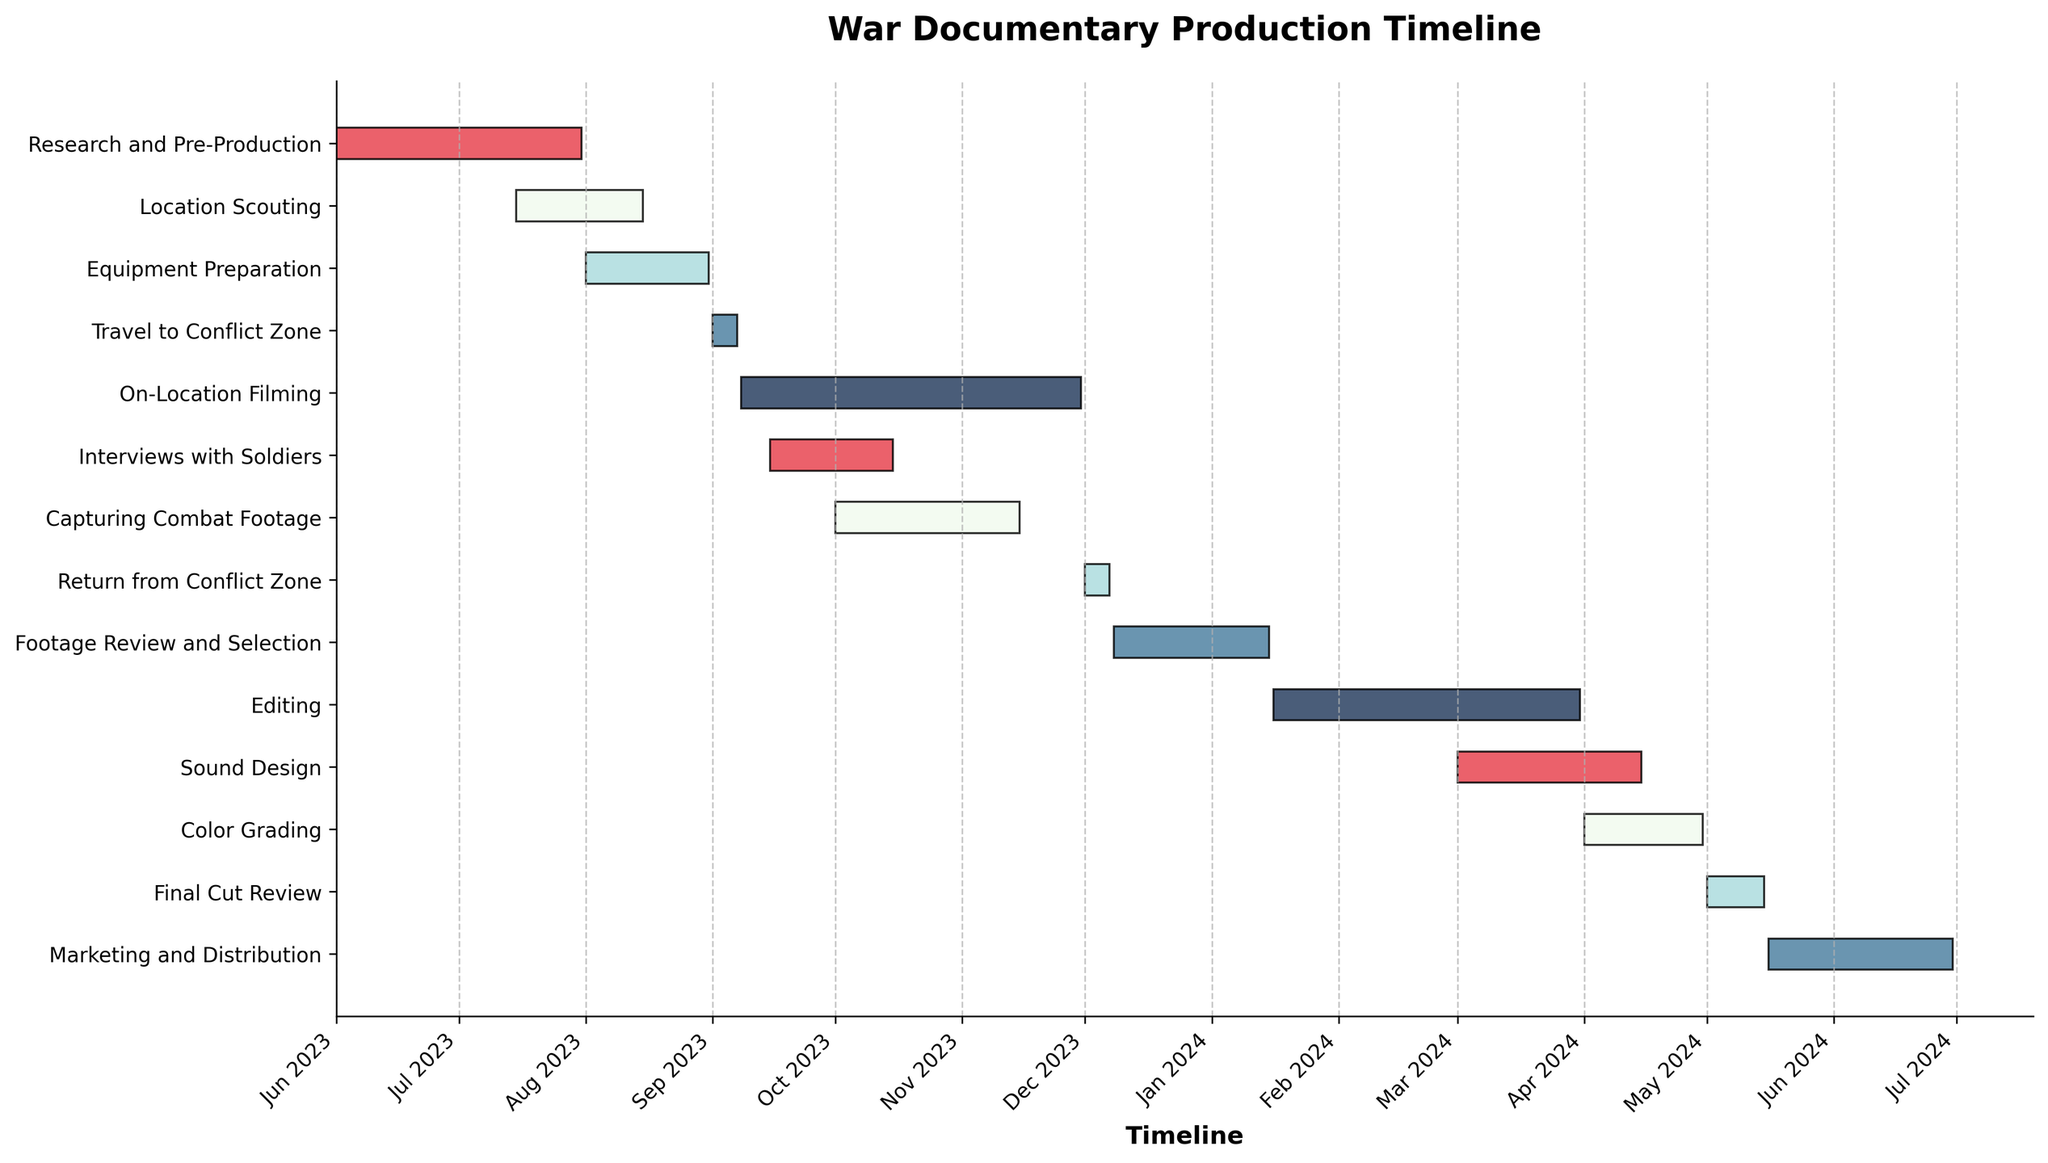What is the title of the Gantt Chart? The title of the Gantt Chart is displayed at the top center of the figure.
Answer: War Documentary Production Timeline What is the earliest task start date and which task does it belong to? By looking at the dates on the left side of each task bar, "Research and Pre-Production" starts on June 1, 2023, which is the earliest date.
Answer: June 1, 2023; Research and Pre-Production How many tasks are in the Filming phase? By examining the task list, the Filming phase includes "Travel to Conflict Zone", "On-Location Filming", "Interviews with Soldiers", "Capturing Combat Footage", and "Return from Conflict Zone".
Answer: 5 When does the "On-Location Filming" start and end? The position of the "On-Location Filming" bar shows it starts on September 8, 2023, and ends on November 30, 2023.
Answer: September 8, 2023; November 30, 2023 Which task has the longest duration, and what is that duration? By comparing the lengths of the bars horizontally, "On-Location Filming" has the longest duration from September 8, 2023, to November 30, 2023. The duration is calculated as November 30 - September 8 = 83 days.
Answer: On-Location Filming; 83 days How long does "Editing" take, and when does it occur? The "Editing" task bar starts at January 16, 2024, and ends at March 31, 2024. The duration is calculated as March 31 - January 16 = 75 days.
Answer: 75 days; January 16, 2024, to March 31, 2024 Which two tasks overlap in October 2023? By checking the timeline for October 2023, "On-Location Filming" and "Capturing Combat Footage" both have bars extending into this month.
Answer: On-Location Filming and Capturing Combat Footage Is there any task that spans across two calendar years? By looking at the dates, "Footage Review and Selection" starts in December 2023 and ends in January 2024. Therefore, it spans two calendar years.
Answer: Footage Review and Selection What is the total duration of the post-production phase? Post-production tasks include "Footage Review and Selection", "Editing", "Sound Design", "Color Grading", and "Final Cut Review". Their combined durations are: 39 days + 75 days + 45 days + 30 days + 15 days = 204 days for post-production. To determine the exact dates, let's sum the individual durations.
Answer: 204 days What are the colors used to represent the different phases in the Gantt Chart? The chart uses five different colors repeated for the different tasks. These are visually red, light blue, teal, blue, and dark blue.
Answer: Red, Light Blue, Teal, Blue, Dark Blue 